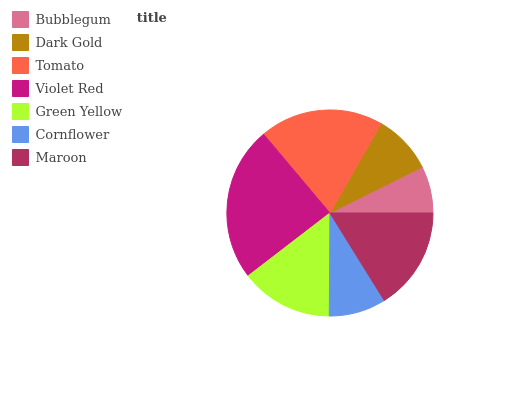Is Bubblegum the minimum?
Answer yes or no. Yes. Is Violet Red the maximum?
Answer yes or no. Yes. Is Dark Gold the minimum?
Answer yes or no. No. Is Dark Gold the maximum?
Answer yes or no. No. Is Dark Gold greater than Bubblegum?
Answer yes or no. Yes. Is Bubblegum less than Dark Gold?
Answer yes or no. Yes. Is Bubblegum greater than Dark Gold?
Answer yes or no. No. Is Dark Gold less than Bubblegum?
Answer yes or no. No. Is Green Yellow the high median?
Answer yes or no. Yes. Is Green Yellow the low median?
Answer yes or no. Yes. Is Tomato the high median?
Answer yes or no. No. Is Cornflower the low median?
Answer yes or no. No. 